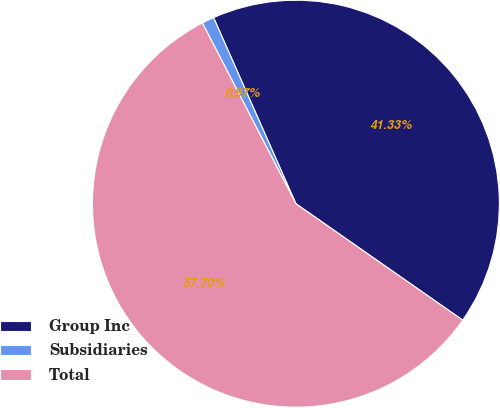Convert chart. <chart><loc_0><loc_0><loc_500><loc_500><pie_chart><fcel>Group Inc<fcel>Subsidiaries<fcel>Total<nl><fcel>41.33%<fcel>0.97%<fcel>57.7%<nl></chart> 